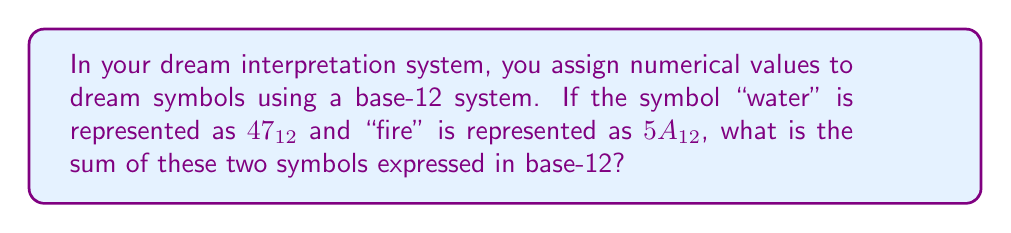What is the answer to this math problem? To solve this problem, we need to add the two base-12 numbers and express the result in base-12. Let's break it down step by step:

1) First, let's understand what these numbers mean:
   $47_{12}$ = $4 * 12^1 + 7 * 12^0 = 48 + 7 = 55$ in base-10
   $5A_{12}$ = $5 * 12^1 + 10 * 12^0 = 60 + 10 = 70$ in base-10 (note that A in base-12 represents 10)

2) Now, let's add these base-10 numbers:
   $55 + 70 = 125$ in base-10

3) To convert 125 (base-10) back to base-12, we divide by 12 repeatedly and keep track of the remainders:

   $125 \div 12 = 10$ remainder $5$
   $10 \div 12 = 0$ remainder $10$ (which is represented as 'A' in base-12)

4) Reading the remainders from bottom to top gives us the base-12 number:
   $125_{10} = A5_{12}$

Therefore, the sum of "water" ($47_{12}$) and "fire" ($5A_{12}$) in your dream symbol number system is $A5_{12}$.
Answer: $A5_{12}$ 